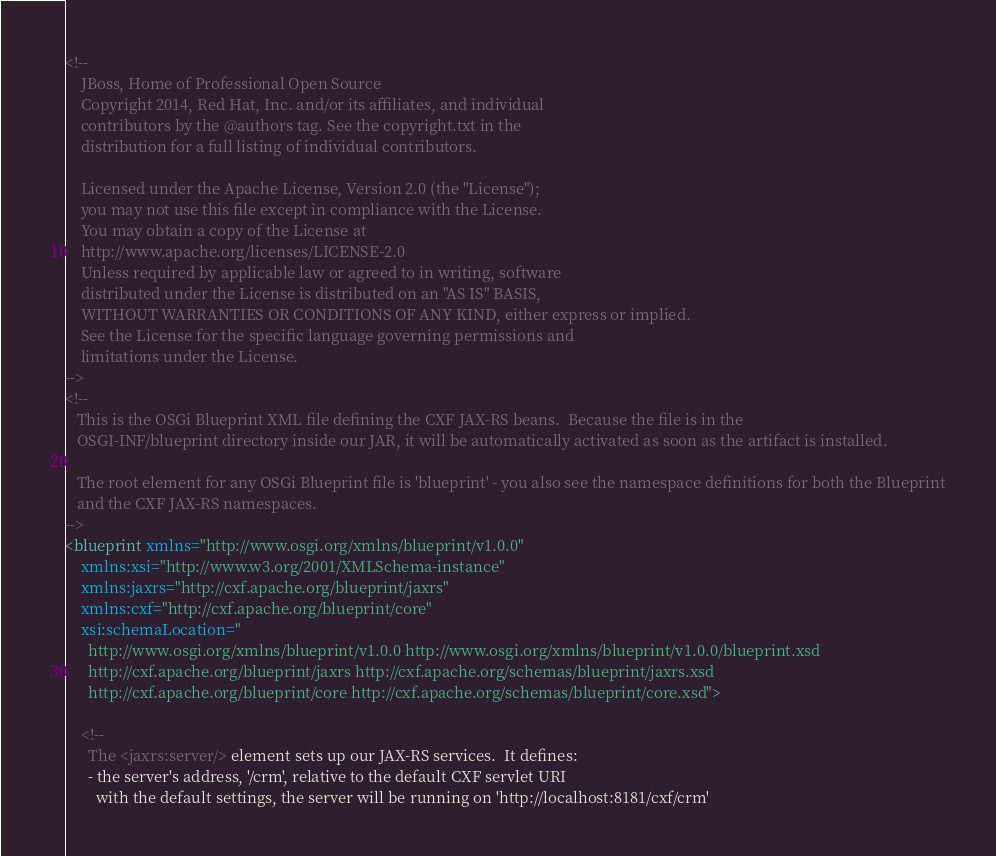Convert code to text. <code><loc_0><loc_0><loc_500><loc_500><_XML_><!--
    JBoss, Home of Professional Open Source
    Copyright 2014, Red Hat, Inc. and/or its affiliates, and individual
    contributors by the @authors tag. See the copyright.txt in the
    distribution for a full listing of individual contributors.

    Licensed under the Apache License, Version 2.0 (the "License");
    you may not use this file except in compliance with the License.
    You may obtain a copy of the License at
    http://www.apache.org/licenses/LICENSE-2.0
    Unless required by applicable law or agreed to in writing, software
    distributed under the License is distributed on an "AS IS" BASIS,
    WITHOUT WARRANTIES OR CONDITIONS OF ANY KIND, either express or implied.
    See the License for the specific language governing permissions and
    limitations under the License.
-->
<!--
   This is the OSGi Blueprint XML file defining the CXF JAX-RS beans.  Because the file is in the
   OSGI-INF/blueprint directory inside our JAR, it will be automatically activated as soon as the artifact is installed.

   The root element for any OSGi Blueprint file is 'blueprint' - you also see the namespace definitions for both the Blueprint
   and the CXF JAX-RS namespaces.
-->
<blueprint xmlns="http://www.osgi.org/xmlns/blueprint/v1.0.0"
    xmlns:xsi="http://www.w3.org/2001/XMLSchema-instance"
    xmlns:jaxrs="http://cxf.apache.org/blueprint/jaxrs"
    xmlns:cxf="http://cxf.apache.org/blueprint/core"
    xsi:schemaLocation="
      http://www.osgi.org/xmlns/blueprint/v1.0.0 http://www.osgi.org/xmlns/blueprint/v1.0.0/blueprint.xsd
      http://cxf.apache.org/blueprint/jaxrs http://cxf.apache.org/schemas/blueprint/jaxrs.xsd
      http://cxf.apache.org/blueprint/core http://cxf.apache.org/schemas/blueprint/core.xsd">

    <!--
      The <jaxrs:server/> element sets up our JAX-RS services.  It defines:
      - the server's address, '/crm', relative to the default CXF servlet URI
        with the default settings, the server will be running on 'http://localhost:8181/cxf/crm'</code> 